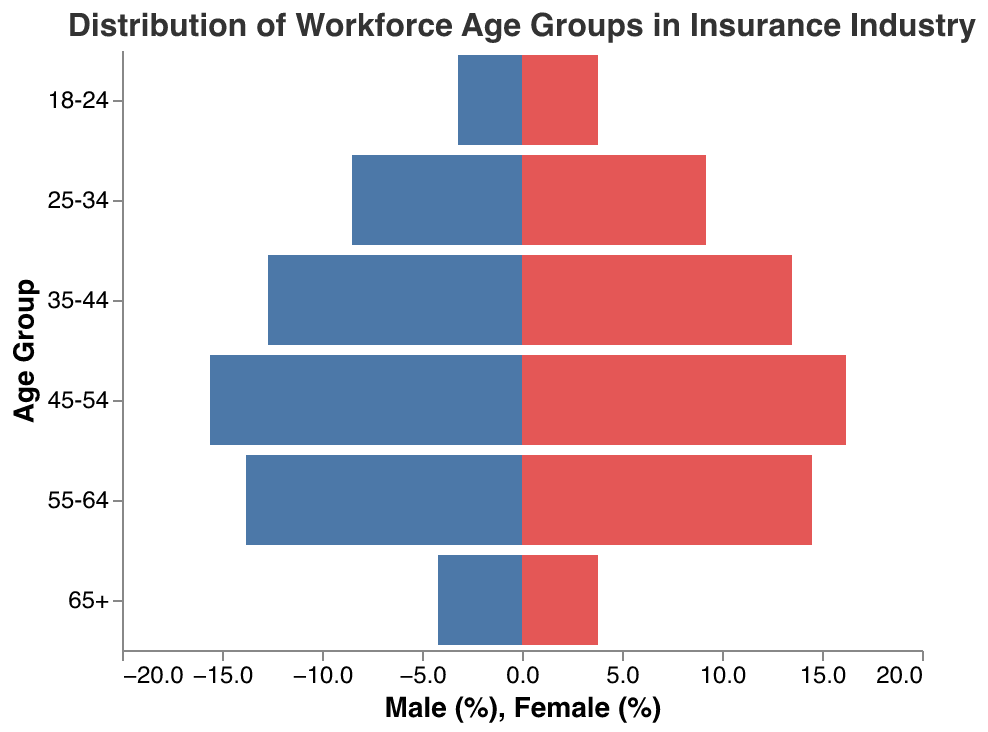What is the title of the figure? The figure's title is displayed at the top in larger font, indicating the main topic of the chart.
Answer: Distribution of Workforce Age Groups in Insurance Industry What is the percentage of males in the 35-44 age group? The percentage of males in various age groups is represented by the blue bars extending to the left. The 35-44 age group male percentage is clearly labeled.
Answer: 12.7% What is the difference in percentage between males and females in the 55-64 age group? The blue bar represents males and the red bar represents females. For the 55-64 age group, males are at 13.8% and females are at 14.5%. The difference is calculated as 14.5 - 13.8.
Answer: 0.7% Which age group has the highest female workforce percentage? By examining the lengths of the red bars, it is evident which age group has the longest bar representing the highest percentage.
Answer: 45-54 Are there more males or females in the 25-34 age group? By comparing the lengths of the blue and red bars for the 25-34 age group, one can see which is longer.
Answer: Females What is the combined workforce percentage for both genders in the 65+ age group? Add the male and female percentages for the 65+ age group: 4.2 (male) + 3.8 (female).
Answer: 8% Which age group has the smallest discrepancy in workforce percentage between males and females? Calculate the absolute differences for each age group and identify the one with the smallest difference.
Answer: 18-24 What percentage of the workforce in the 45-54 age group is composed of males? The percentage for males in each age group is represented by the blue bars. Locate the 45-54 group and read the percentage value.
Answer: 15.6% How does the male percentage in the 18-24 group compare to the female percentage in the same group? Compare the lengths of the blue bar (male) and red bar (female) in the 18-24 age group.
Answer: 3.2% (male) vs. 3.8% (female), females have a higher percentage 